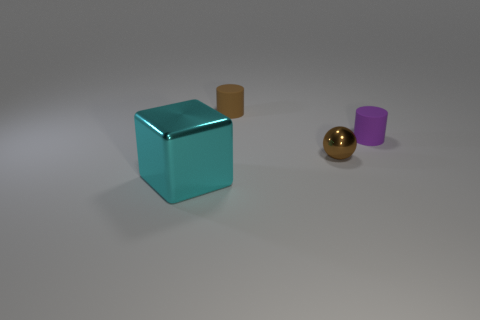Subtract all cubes. How many objects are left? 3 Add 4 green metallic blocks. How many objects exist? 8 Subtract all gray blocks. How many green balls are left? 0 Subtract all tiny metallic balls. Subtract all blue matte things. How many objects are left? 3 Add 1 small brown cylinders. How many small brown cylinders are left? 2 Add 1 cyan things. How many cyan things exist? 2 Subtract 0 blue cubes. How many objects are left? 4 Subtract all blue cylinders. Subtract all brown cubes. How many cylinders are left? 2 